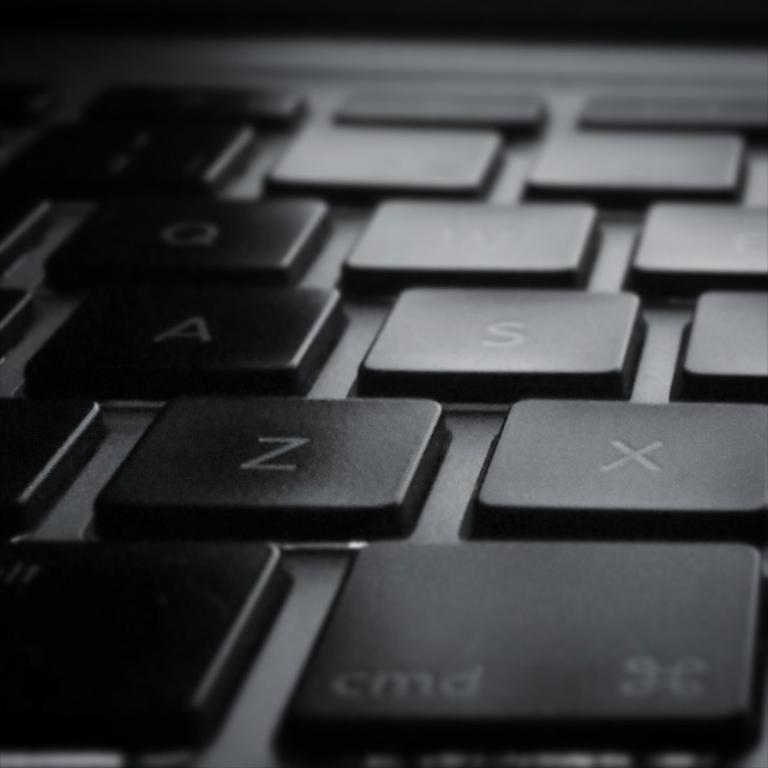Provide a one-sentence caption for the provided image. A laptop's black keys are shown with the letters Z and X are visible. 